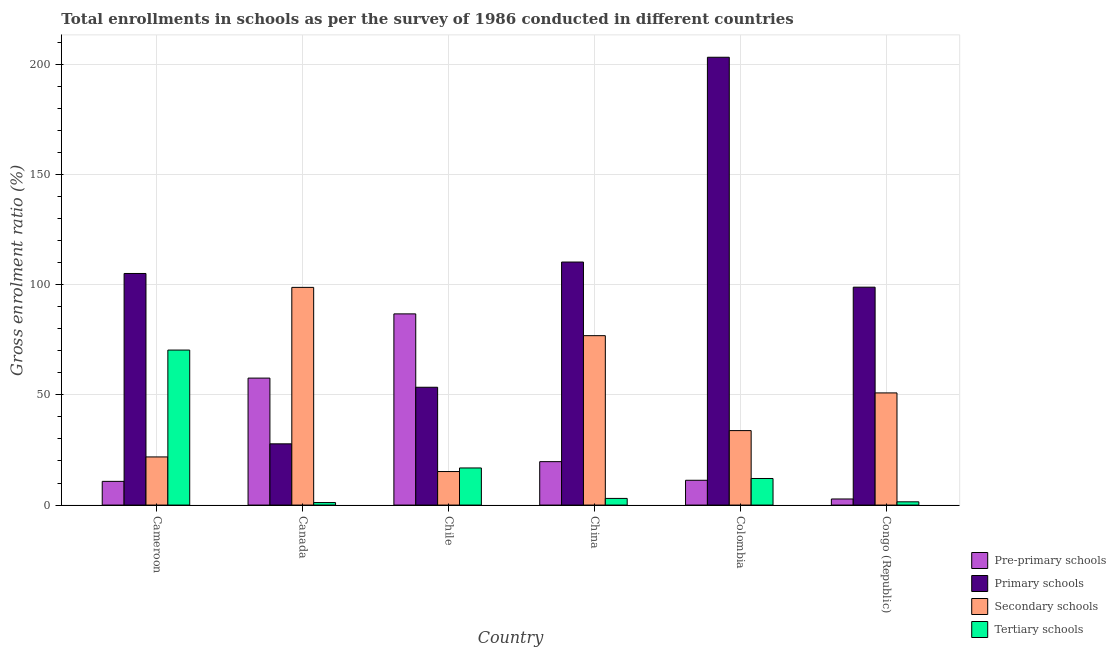How many different coloured bars are there?
Your answer should be compact. 4. How many groups of bars are there?
Make the answer very short. 6. How many bars are there on the 6th tick from the left?
Provide a short and direct response. 4. How many bars are there on the 2nd tick from the right?
Offer a very short reply. 4. What is the gross enrolment ratio in pre-primary schools in Cameroon?
Provide a succinct answer. 10.75. Across all countries, what is the maximum gross enrolment ratio in pre-primary schools?
Provide a succinct answer. 86.73. Across all countries, what is the minimum gross enrolment ratio in primary schools?
Your answer should be compact. 27.78. In which country was the gross enrolment ratio in primary schools maximum?
Ensure brevity in your answer.  Colombia. What is the total gross enrolment ratio in secondary schools in the graph?
Keep it short and to the point. 297.31. What is the difference between the gross enrolment ratio in pre-primary schools in Cameroon and that in Colombia?
Your answer should be very brief. -0.5. What is the difference between the gross enrolment ratio in secondary schools in Canada and the gross enrolment ratio in primary schools in Cameroon?
Your response must be concise. -6.31. What is the average gross enrolment ratio in primary schools per country?
Ensure brevity in your answer.  99.75. What is the difference between the gross enrolment ratio in tertiary schools and gross enrolment ratio in pre-primary schools in Chile?
Your answer should be compact. -69.9. What is the ratio of the gross enrolment ratio in tertiary schools in Cameroon to that in Chile?
Give a very brief answer. 4.18. Is the gross enrolment ratio in primary schools in Canada less than that in China?
Give a very brief answer. Yes. Is the difference between the gross enrolment ratio in secondary schools in Cameroon and Colombia greater than the difference between the gross enrolment ratio in pre-primary schools in Cameroon and Colombia?
Keep it short and to the point. No. What is the difference between the highest and the second highest gross enrolment ratio in pre-primary schools?
Keep it short and to the point. 29.14. What is the difference between the highest and the lowest gross enrolment ratio in pre-primary schools?
Offer a very short reply. 83.97. Is it the case that in every country, the sum of the gross enrolment ratio in tertiary schools and gross enrolment ratio in pre-primary schools is greater than the sum of gross enrolment ratio in secondary schools and gross enrolment ratio in primary schools?
Give a very brief answer. No. What does the 3rd bar from the left in Chile represents?
Provide a short and direct response. Secondary schools. What does the 3rd bar from the right in Chile represents?
Your response must be concise. Primary schools. How many bars are there?
Ensure brevity in your answer.  24. Are all the bars in the graph horizontal?
Your response must be concise. No. Where does the legend appear in the graph?
Ensure brevity in your answer.  Bottom right. How are the legend labels stacked?
Your answer should be very brief. Vertical. What is the title of the graph?
Keep it short and to the point. Total enrollments in schools as per the survey of 1986 conducted in different countries. Does "Social Protection" appear as one of the legend labels in the graph?
Give a very brief answer. No. What is the label or title of the X-axis?
Offer a very short reply. Country. What is the label or title of the Y-axis?
Make the answer very short. Gross enrolment ratio (%). What is the Gross enrolment ratio (%) in Pre-primary schools in Cameroon?
Your answer should be very brief. 10.75. What is the Gross enrolment ratio (%) of Primary schools in Cameroon?
Provide a short and direct response. 105.06. What is the Gross enrolment ratio (%) of Secondary schools in Cameroon?
Offer a terse response. 21.84. What is the Gross enrolment ratio (%) of Tertiary schools in Cameroon?
Make the answer very short. 70.31. What is the Gross enrolment ratio (%) in Pre-primary schools in Canada?
Ensure brevity in your answer.  57.6. What is the Gross enrolment ratio (%) in Primary schools in Canada?
Your answer should be compact. 27.78. What is the Gross enrolment ratio (%) in Secondary schools in Canada?
Ensure brevity in your answer.  98.75. What is the Gross enrolment ratio (%) of Tertiary schools in Canada?
Provide a short and direct response. 1.14. What is the Gross enrolment ratio (%) in Pre-primary schools in Chile?
Provide a short and direct response. 86.73. What is the Gross enrolment ratio (%) of Primary schools in Chile?
Ensure brevity in your answer.  53.45. What is the Gross enrolment ratio (%) in Secondary schools in Chile?
Give a very brief answer. 15.21. What is the Gross enrolment ratio (%) of Tertiary schools in Chile?
Offer a terse response. 16.84. What is the Gross enrolment ratio (%) in Pre-primary schools in China?
Give a very brief answer. 19.7. What is the Gross enrolment ratio (%) in Primary schools in China?
Keep it short and to the point. 110.25. What is the Gross enrolment ratio (%) in Secondary schools in China?
Your answer should be very brief. 76.85. What is the Gross enrolment ratio (%) in Tertiary schools in China?
Your response must be concise. 3.02. What is the Gross enrolment ratio (%) of Pre-primary schools in Colombia?
Provide a succinct answer. 11.25. What is the Gross enrolment ratio (%) in Primary schools in Colombia?
Give a very brief answer. 203.14. What is the Gross enrolment ratio (%) of Secondary schools in Colombia?
Offer a very short reply. 33.78. What is the Gross enrolment ratio (%) in Tertiary schools in Colombia?
Give a very brief answer. 12.06. What is the Gross enrolment ratio (%) in Pre-primary schools in Congo (Republic)?
Offer a terse response. 2.76. What is the Gross enrolment ratio (%) in Primary schools in Congo (Republic)?
Provide a short and direct response. 98.85. What is the Gross enrolment ratio (%) in Secondary schools in Congo (Republic)?
Provide a succinct answer. 50.88. What is the Gross enrolment ratio (%) in Tertiary schools in Congo (Republic)?
Offer a terse response. 1.48. Across all countries, what is the maximum Gross enrolment ratio (%) of Pre-primary schools?
Keep it short and to the point. 86.73. Across all countries, what is the maximum Gross enrolment ratio (%) in Primary schools?
Offer a very short reply. 203.14. Across all countries, what is the maximum Gross enrolment ratio (%) in Secondary schools?
Make the answer very short. 98.75. Across all countries, what is the maximum Gross enrolment ratio (%) of Tertiary schools?
Your answer should be compact. 70.31. Across all countries, what is the minimum Gross enrolment ratio (%) of Pre-primary schools?
Provide a succinct answer. 2.76. Across all countries, what is the minimum Gross enrolment ratio (%) of Primary schools?
Make the answer very short. 27.78. Across all countries, what is the minimum Gross enrolment ratio (%) of Secondary schools?
Your answer should be very brief. 15.21. Across all countries, what is the minimum Gross enrolment ratio (%) of Tertiary schools?
Your answer should be very brief. 1.14. What is the total Gross enrolment ratio (%) of Pre-primary schools in the graph?
Your answer should be very brief. 188.79. What is the total Gross enrolment ratio (%) in Primary schools in the graph?
Give a very brief answer. 598.52. What is the total Gross enrolment ratio (%) in Secondary schools in the graph?
Provide a short and direct response. 297.31. What is the total Gross enrolment ratio (%) in Tertiary schools in the graph?
Ensure brevity in your answer.  104.84. What is the difference between the Gross enrolment ratio (%) of Pre-primary schools in Cameroon and that in Canada?
Keep it short and to the point. -46.84. What is the difference between the Gross enrolment ratio (%) of Primary schools in Cameroon and that in Canada?
Make the answer very short. 77.28. What is the difference between the Gross enrolment ratio (%) of Secondary schools in Cameroon and that in Canada?
Ensure brevity in your answer.  -76.91. What is the difference between the Gross enrolment ratio (%) in Tertiary schools in Cameroon and that in Canada?
Your answer should be very brief. 69.17. What is the difference between the Gross enrolment ratio (%) of Pre-primary schools in Cameroon and that in Chile?
Give a very brief answer. -75.98. What is the difference between the Gross enrolment ratio (%) in Primary schools in Cameroon and that in Chile?
Your answer should be very brief. 51.61. What is the difference between the Gross enrolment ratio (%) in Secondary schools in Cameroon and that in Chile?
Make the answer very short. 6.63. What is the difference between the Gross enrolment ratio (%) in Tertiary schools in Cameroon and that in Chile?
Provide a short and direct response. 53.48. What is the difference between the Gross enrolment ratio (%) of Pre-primary schools in Cameroon and that in China?
Give a very brief answer. -8.95. What is the difference between the Gross enrolment ratio (%) in Primary schools in Cameroon and that in China?
Your answer should be compact. -5.19. What is the difference between the Gross enrolment ratio (%) in Secondary schools in Cameroon and that in China?
Keep it short and to the point. -55.01. What is the difference between the Gross enrolment ratio (%) of Tertiary schools in Cameroon and that in China?
Make the answer very short. 67.29. What is the difference between the Gross enrolment ratio (%) in Pre-primary schools in Cameroon and that in Colombia?
Your response must be concise. -0.5. What is the difference between the Gross enrolment ratio (%) in Primary schools in Cameroon and that in Colombia?
Give a very brief answer. -98.08. What is the difference between the Gross enrolment ratio (%) in Secondary schools in Cameroon and that in Colombia?
Your answer should be very brief. -11.95. What is the difference between the Gross enrolment ratio (%) in Tertiary schools in Cameroon and that in Colombia?
Provide a short and direct response. 58.25. What is the difference between the Gross enrolment ratio (%) in Pre-primary schools in Cameroon and that in Congo (Republic)?
Ensure brevity in your answer.  7.99. What is the difference between the Gross enrolment ratio (%) of Primary schools in Cameroon and that in Congo (Republic)?
Keep it short and to the point. 6.21. What is the difference between the Gross enrolment ratio (%) of Secondary schools in Cameroon and that in Congo (Republic)?
Give a very brief answer. -29.04. What is the difference between the Gross enrolment ratio (%) in Tertiary schools in Cameroon and that in Congo (Republic)?
Provide a succinct answer. 68.83. What is the difference between the Gross enrolment ratio (%) in Pre-primary schools in Canada and that in Chile?
Make the answer very short. -29.14. What is the difference between the Gross enrolment ratio (%) in Primary schools in Canada and that in Chile?
Offer a terse response. -25.67. What is the difference between the Gross enrolment ratio (%) of Secondary schools in Canada and that in Chile?
Offer a very short reply. 83.54. What is the difference between the Gross enrolment ratio (%) in Tertiary schools in Canada and that in Chile?
Offer a very short reply. -15.69. What is the difference between the Gross enrolment ratio (%) in Pre-primary schools in Canada and that in China?
Your answer should be compact. 37.9. What is the difference between the Gross enrolment ratio (%) in Primary schools in Canada and that in China?
Offer a terse response. -82.47. What is the difference between the Gross enrolment ratio (%) of Secondary schools in Canada and that in China?
Provide a short and direct response. 21.9. What is the difference between the Gross enrolment ratio (%) of Tertiary schools in Canada and that in China?
Keep it short and to the point. -1.88. What is the difference between the Gross enrolment ratio (%) of Pre-primary schools in Canada and that in Colombia?
Your answer should be compact. 46.34. What is the difference between the Gross enrolment ratio (%) of Primary schools in Canada and that in Colombia?
Make the answer very short. -175.36. What is the difference between the Gross enrolment ratio (%) of Secondary schools in Canada and that in Colombia?
Give a very brief answer. 64.96. What is the difference between the Gross enrolment ratio (%) in Tertiary schools in Canada and that in Colombia?
Offer a very short reply. -10.92. What is the difference between the Gross enrolment ratio (%) in Pre-primary schools in Canada and that in Congo (Republic)?
Provide a succinct answer. 54.83. What is the difference between the Gross enrolment ratio (%) in Primary schools in Canada and that in Congo (Republic)?
Give a very brief answer. -71.07. What is the difference between the Gross enrolment ratio (%) of Secondary schools in Canada and that in Congo (Republic)?
Offer a very short reply. 47.87. What is the difference between the Gross enrolment ratio (%) in Tertiary schools in Canada and that in Congo (Republic)?
Your response must be concise. -0.34. What is the difference between the Gross enrolment ratio (%) of Pre-primary schools in Chile and that in China?
Ensure brevity in your answer.  67.03. What is the difference between the Gross enrolment ratio (%) in Primary schools in Chile and that in China?
Offer a terse response. -56.8. What is the difference between the Gross enrolment ratio (%) of Secondary schools in Chile and that in China?
Offer a terse response. -61.64. What is the difference between the Gross enrolment ratio (%) of Tertiary schools in Chile and that in China?
Your answer should be very brief. 13.81. What is the difference between the Gross enrolment ratio (%) of Pre-primary schools in Chile and that in Colombia?
Provide a short and direct response. 75.48. What is the difference between the Gross enrolment ratio (%) of Primary schools in Chile and that in Colombia?
Provide a short and direct response. -149.69. What is the difference between the Gross enrolment ratio (%) of Secondary schools in Chile and that in Colombia?
Keep it short and to the point. -18.58. What is the difference between the Gross enrolment ratio (%) of Tertiary schools in Chile and that in Colombia?
Provide a succinct answer. 4.78. What is the difference between the Gross enrolment ratio (%) of Pre-primary schools in Chile and that in Congo (Republic)?
Your answer should be compact. 83.97. What is the difference between the Gross enrolment ratio (%) in Primary schools in Chile and that in Congo (Republic)?
Your answer should be very brief. -45.4. What is the difference between the Gross enrolment ratio (%) of Secondary schools in Chile and that in Congo (Republic)?
Your answer should be very brief. -35.67. What is the difference between the Gross enrolment ratio (%) of Tertiary schools in Chile and that in Congo (Republic)?
Your answer should be very brief. 15.36. What is the difference between the Gross enrolment ratio (%) of Pre-primary schools in China and that in Colombia?
Make the answer very short. 8.45. What is the difference between the Gross enrolment ratio (%) of Primary schools in China and that in Colombia?
Make the answer very short. -92.89. What is the difference between the Gross enrolment ratio (%) in Secondary schools in China and that in Colombia?
Offer a terse response. 43.06. What is the difference between the Gross enrolment ratio (%) of Tertiary schools in China and that in Colombia?
Ensure brevity in your answer.  -9.04. What is the difference between the Gross enrolment ratio (%) in Pre-primary schools in China and that in Congo (Republic)?
Your answer should be compact. 16.94. What is the difference between the Gross enrolment ratio (%) in Primary schools in China and that in Congo (Republic)?
Provide a short and direct response. 11.4. What is the difference between the Gross enrolment ratio (%) of Secondary schools in China and that in Congo (Republic)?
Your response must be concise. 25.97. What is the difference between the Gross enrolment ratio (%) in Tertiary schools in China and that in Congo (Republic)?
Offer a very short reply. 1.54. What is the difference between the Gross enrolment ratio (%) in Pre-primary schools in Colombia and that in Congo (Republic)?
Offer a terse response. 8.49. What is the difference between the Gross enrolment ratio (%) in Primary schools in Colombia and that in Congo (Republic)?
Your answer should be compact. 104.3. What is the difference between the Gross enrolment ratio (%) of Secondary schools in Colombia and that in Congo (Republic)?
Make the answer very short. -17.1. What is the difference between the Gross enrolment ratio (%) in Tertiary schools in Colombia and that in Congo (Republic)?
Provide a short and direct response. 10.58. What is the difference between the Gross enrolment ratio (%) in Pre-primary schools in Cameroon and the Gross enrolment ratio (%) in Primary schools in Canada?
Provide a succinct answer. -17.02. What is the difference between the Gross enrolment ratio (%) of Pre-primary schools in Cameroon and the Gross enrolment ratio (%) of Secondary schools in Canada?
Offer a terse response. -88. What is the difference between the Gross enrolment ratio (%) in Pre-primary schools in Cameroon and the Gross enrolment ratio (%) in Tertiary schools in Canada?
Offer a very short reply. 9.61. What is the difference between the Gross enrolment ratio (%) of Primary schools in Cameroon and the Gross enrolment ratio (%) of Secondary schools in Canada?
Make the answer very short. 6.31. What is the difference between the Gross enrolment ratio (%) in Primary schools in Cameroon and the Gross enrolment ratio (%) in Tertiary schools in Canada?
Offer a very short reply. 103.92. What is the difference between the Gross enrolment ratio (%) in Secondary schools in Cameroon and the Gross enrolment ratio (%) in Tertiary schools in Canada?
Offer a terse response. 20.7. What is the difference between the Gross enrolment ratio (%) of Pre-primary schools in Cameroon and the Gross enrolment ratio (%) of Primary schools in Chile?
Your answer should be compact. -42.69. What is the difference between the Gross enrolment ratio (%) of Pre-primary schools in Cameroon and the Gross enrolment ratio (%) of Secondary schools in Chile?
Make the answer very short. -4.46. What is the difference between the Gross enrolment ratio (%) of Pre-primary schools in Cameroon and the Gross enrolment ratio (%) of Tertiary schools in Chile?
Provide a short and direct response. -6.08. What is the difference between the Gross enrolment ratio (%) in Primary schools in Cameroon and the Gross enrolment ratio (%) in Secondary schools in Chile?
Make the answer very short. 89.85. What is the difference between the Gross enrolment ratio (%) in Primary schools in Cameroon and the Gross enrolment ratio (%) in Tertiary schools in Chile?
Offer a very short reply. 88.22. What is the difference between the Gross enrolment ratio (%) of Secondary schools in Cameroon and the Gross enrolment ratio (%) of Tertiary schools in Chile?
Provide a short and direct response. 5. What is the difference between the Gross enrolment ratio (%) in Pre-primary schools in Cameroon and the Gross enrolment ratio (%) in Primary schools in China?
Provide a short and direct response. -99.5. What is the difference between the Gross enrolment ratio (%) in Pre-primary schools in Cameroon and the Gross enrolment ratio (%) in Secondary schools in China?
Ensure brevity in your answer.  -66.1. What is the difference between the Gross enrolment ratio (%) of Pre-primary schools in Cameroon and the Gross enrolment ratio (%) of Tertiary schools in China?
Your answer should be compact. 7.73. What is the difference between the Gross enrolment ratio (%) in Primary schools in Cameroon and the Gross enrolment ratio (%) in Secondary schools in China?
Your answer should be very brief. 28.21. What is the difference between the Gross enrolment ratio (%) of Primary schools in Cameroon and the Gross enrolment ratio (%) of Tertiary schools in China?
Make the answer very short. 102.04. What is the difference between the Gross enrolment ratio (%) in Secondary schools in Cameroon and the Gross enrolment ratio (%) in Tertiary schools in China?
Ensure brevity in your answer.  18.82. What is the difference between the Gross enrolment ratio (%) in Pre-primary schools in Cameroon and the Gross enrolment ratio (%) in Primary schools in Colombia?
Offer a terse response. -192.39. What is the difference between the Gross enrolment ratio (%) of Pre-primary schools in Cameroon and the Gross enrolment ratio (%) of Secondary schools in Colombia?
Offer a very short reply. -23.03. What is the difference between the Gross enrolment ratio (%) in Pre-primary schools in Cameroon and the Gross enrolment ratio (%) in Tertiary schools in Colombia?
Your response must be concise. -1.3. What is the difference between the Gross enrolment ratio (%) of Primary schools in Cameroon and the Gross enrolment ratio (%) of Secondary schools in Colombia?
Your answer should be compact. 71.27. What is the difference between the Gross enrolment ratio (%) of Primary schools in Cameroon and the Gross enrolment ratio (%) of Tertiary schools in Colombia?
Provide a short and direct response. 93. What is the difference between the Gross enrolment ratio (%) of Secondary schools in Cameroon and the Gross enrolment ratio (%) of Tertiary schools in Colombia?
Make the answer very short. 9.78. What is the difference between the Gross enrolment ratio (%) in Pre-primary schools in Cameroon and the Gross enrolment ratio (%) in Primary schools in Congo (Republic)?
Your answer should be very brief. -88.09. What is the difference between the Gross enrolment ratio (%) in Pre-primary schools in Cameroon and the Gross enrolment ratio (%) in Secondary schools in Congo (Republic)?
Your answer should be compact. -40.13. What is the difference between the Gross enrolment ratio (%) in Pre-primary schools in Cameroon and the Gross enrolment ratio (%) in Tertiary schools in Congo (Republic)?
Provide a succinct answer. 9.28. What is the difference between the Gross enrolment ratio (%) in Primary schools in Cameroon and the Gross enrolment ratio (%) in Secondary schools in Congo (Republic)?
Provide a short and direct response. 54.18. What is the difference between the Gross enrolment ratio (%) in Primary schools in Cameroon and the Gross enrolment ratio (%) in Tertiary schools in Congo (Republic)?
Offer a very short reply. 103.58. What is the difference between the Gross enrolment ratio (%) of Secondary schools in Cameroon and the Gross enrolment ratio (%) of Tertiary schools in Congo (Republic)?
Your answer should be compact. 20.36. What is the difference between the Gross enrolment ratio (%) in Pre-primary schools in Canada and the Gross enrolment ratio (%) in Primary schools in Chile?
Keep it short and to the point. 4.15. What is the difference between the Gross enrolment ratio (%) of Pre-primary schools in Canada and the Gross enrolment ratio (%) of Secondary schools in Chile?
Provide a succinct answer. 42.39. What is the difference between the Gross enrolment ratio (%) of Pre-primary schools in Canada and the Gross enrolment ratio (%) of Tertiary schools in Chile?
Offer a terse response. 40.76. What is the difference between the Gross enrolment ratio (%) in Primary schools in Canada and the Gross enrolment ratio (%) in Secondary schools in Chile?
Provide a short and direct response. 12.57. What is the difference between the Gross enrolment ratio (%) of Primary schools in Canada and the Gross enrolment ratio (%) of Tertiary schools in Chile?
Give a very brief answer. 10.94. What is the difference between the Gross enrolment ratio (%) of Secondary schools in Canada and the Gross enrolment ratio (%) of Tertiary schools in Chile?
Your response must be concise. 81.91. What is the difference between the Gross enrolment ratio (%) in Pre-primary schools in Canada and the Gross enrolment ratio (%) in Primary schools in China?
Provide a succinct answer. -52.65. What is the difference between the Gross enrolment ratio (%) of Pre-primary schools in Canada and the Gross enrolment ratio (%) of Secondary schools in China?
Keep it short and to the point. -19.25. What is the difference between the Gross enrolment ratio (%) in Pre-primary schools in Canada and the Gross enrolment ratio (%) in Tertiary schools in China?
Offer a very short reply. 54.58. What is the difference between the Gross enrolment ratio (%) in Primary schools in Canada and the Gross enrolment ratio (%) in Secondary schools in China?
Your answer should be compact. -49.07. What is the difference between the Gross enrolment ratio (%) of Primary schools in Canada and the Gross enrolment ratio (%) of Tertiary schools in China?
Provide a succinct answer. 24.76. What is the difference between the Gross enrolment ratio (%) in Secondary schools in Canada and the Gross enrolment ratio (%) in Tertiary schools in China?
Keep it short and to the point. 95.73. What is the difference between the Gross enrolment ratio (%) in Pre-primary schools in Canada and the Gross enrolment ratio (%) in Primary schools in Colombia?
Make the answer very short. -145.55. What is the difference between the Gross enrolment ratio (%) in Pre-primary schools in Canada and the Gross enrolment ratio (%) in Secondary schools in Colombia?
Give a very brief answer. 23.81. What is the difference between the Gross enrolment ratio (%) of Pre-primary schools in Canada and the Gross enrolment ratio (%) of Tertiary schools in Colombia?
Offer a terse response. 45.54. What is the difference between the Gross enrolment ratio (%) in Primary schools in Canada and the Gross enrolment ratio (%) in Secondary schools in Colombia?
Your response must be concise. -6.01. What is the difference between the Gross enrolment ratio (%) of Primary schools in Canada and the Gross enrolment ratio (%) of Tertiary schools in Colombia?
Offer a terse response. 15.72. What is the difference between the Gross enrolment ratio (%) in Secondary schools in Canada and the Gross enrolment ratio (%) in Tertiary schools in Colombia?
Your answer should be compact. 86.69. What is the difference between the Gross enrolment ratio (%) in Pre-primary schools in Canada and the Gross enrolment ratio (%) in Primary schools in Congo (Republic)?
Provide a short and direct response. -41.25. What is the difference between the Gross enrolment ratio (%) in Pre-primary schools in Canada and the Gross enrolment ratio (%) in Secondary schools in Congo (Republic)?
Provide a succinct answer. 6.71. What is the difference between the Gross enrolment ratio (%) of Pre-primary schools in Canada and the Gross enrolment ratio (%) of Tertiary schools in Congo (Republic)?
Provide a short and direct response. 56.12. What is the difference between the Gross enrolment ratio (%) in Primary schools in Canada and the Gross enrolment ratio (%) in Secondary schools in Congo (Republic)?
Your answer should be compact. -23.11. What is the difference between the Gross enrolment ratio (%) in Primary schools in Canada and the Gross enrolment ratio (%) in Tertiary schools in Congo (Republic)?
Your response must be concise. 26.3. What is the difference between the Gross enrolment ratio (%) in Secondary schools in Canada and the Gross enrolment ratio (%) in Tertiary schools in Congo (Republic)?
Ensure brevity in your answer.  97.27. What is the difference between the Gross enrolment ratio (%) in Pre-primary schools in Chile and the Gross enrolment ratio (%) in Primary schools in China?
Keep it short and to the point. -23.52. What is the difference between the Gross enrolment ratio (%) in Pre-primary schools in Chile and the Gross enrolment ratio (%) in Secondary schools in China?
Offer a terse response. 9.88. What is the difference between the Gross enrolment ratio (%) in Pre-primary schools in Chile and the Gross enrolment ratio (%) in Tertiary schools in China?
Your answer should be compact. 83.71. What is the difference between the Gross enrolment ratio (%) of Primary schools in Chile and the Gross enrolment ratio (%) of Secondary schools in China?
Ensure brevity in your answer.  -23.4. What is the difference between the Gross enrolment ratio (%) in Primary schools in Chile and the Gross enrolment ratio (%) in Tertiary schools in China?
Offer a terse response. 50.43. What is the difference between the Gross enrolment ratio (%) of Secondary schools in Chile and the Gross enrolment ratio (%) of Tertiary schools in China?
Ensure brevity in your answer.  12.19. What is the difference between the Gross enrolment ratio (%) of Pre-primary schools in Chile and the Gross enrolment ratio (%) of Primary schools in Colombia?
Provide a succinct answer. -116.41. What is the difference between the Gross enrolment ratio (%) in Pre-primary schools in Chile and the Gross enrolment ratio (%) in Secondary schools in Colombia?
Your response must be concise. 52.95. What is the difference between the Gross enrolment ratio (%) in Pre-primary schools in Chile and the Gross enrolment ratio (%) in Tertiary schools in Colombia?
Keep it short and to the point. 74.67. What is the difference between the Gross enrolment ratio (%) of Primary schools in Chile and the Gross enrolment ratio (%) of Secondary schools in Colombia?
Your answer should be very brief. 19.66. What is the difference between the Gross enrolment ratio (%) in Primary schools in Chile and the Gross enrolment ratio (%) in Tertiary schools in Colombia?
Make the answer very short. 41.39. What is the difference between the Gross enrolment ratio (%) of Secondary schools in Chile and the Gross enrolment ratio (%) of Tertiary schools in Colombia?
Provide a short and direct response. 3.15. What is the difference between the Gross enrolment ratio (%) of Pre-primary schools in Chile and the Gross enrolment ratio (%) of Primary schools in Congo (Republic)?
Ensure brevity in your answer.  -12.11. What is the difference between the Gross enrolment ratio (%) of Pre-primary schools in Chile and the Gross enrolment ratio (%) of Secondary schools in Congo (Republic)?
Offer a terse response. 35.85. What is the difference between the Gross enrolment ratio (%) of Pre-primary schools in Chile and the Gross enrolment ratio (%) of Tertiary schools in Congo (Republic)?
Ensure brevity in your answer.  85.25. What is the difference between the Gross enrolment ratio (%) in Primary schools in Chile and the Gross enrolment ratio (%) in Secondary schools in Congo (Republic)?
Provide a succinct answer. 2.56. What is the difference between the Gross enrolment ratio (%) in Primary schools in Chile and the Gross enrolment ratio (%) in Tertiary schools in Congo (Republic)?
Your response must be concise. 51.97. What is the difference between the Gross enrolment ratio (%) in Secondary schools in Chile and the Gross enrolment ratio (%) in Tertiary schools in Congo (Republic)?
Give a very brief answer. 13.73. What is the difference between the Gross enrolment ratio (%) in Pre-primary schools in China and the Gross enrolment ratio (%) in Primary schools in Colombia?
Your answer should be compact. -183.44. What is the difference between the Gross enrolment ratio (%) of Pre-primary schools in China and the Gross enrolment ratio (%) of Secondary schools in Colombia?
Your answer should be compact. -14.09. What is the difference between the Gross enrolment ratio (%) in Pre-primary schools in China and the Gross enrolment ratio (%) in Tertiary schools in Colombia?
Your answer should be very brief. 7.64. What is the difference between the Gross enrolment ratio (%) of Primary schools in China and the Gross enrolment ratio (%) of Secondary schools in Colombia?
Provide a succinct answer. 76.46. What is the difference between the Gross enrolment ratio (%) of Primary schools in China and the Gross enrolment ratio (%) of Tertiary schools in Colombia?
Ensure brevity in your answer.  98.19. What is the difference between the Gross enrolment ratio (%) in Secondary schools in China and the Gross enrolment ratio (%) in Tertiary schools in Colombia?
Ensure brevity in your answer.  64.79. What is the difference between the Gross enrolment ratio (%) of Pre-primary schools in China and the Gross enrolment ratio (%) of Primary schools in Congo (Republic)?
Offer a very short reply. -79.15. What is the difference between the Gross enrolment ratio (%) of Pre-primary schools in China and the Gross enrolment ratio (%) of Secondary schools in Congo (Republic)?
Offer a very short reply. -31.18. What is the difference between the Gross enrolment ratio (%) in Pre-primary schools in China and the Gross enrolment ratio (%) in Tertiary schools in Congo (Republic)?
Offer a very short reply. 18.22. What is the difference between the Gross enrolment ratio (%) of Primary schools in China and the Gross enrolment ratio (%) of Secondary schools in Congo (Republic)?
Your answer should be compact. 59.37. What is the difference between the Gross enrolment ratio (%) in Primary schools in China and the Gross enrolment ratio (%) in Tertiary schools in Congo (Republic)?
Your answer should be compact. 108.77. What is the difference between the Gross enrolment ratio (%) in Secondary schools in China and the Gross enrolment ratio (%) in Tertiary schools in Congo (Republic)?
Offer a very short reply. 75.37. What is the difference between the Gross enrolment ratio (%) of Pre-primary schools in Colombia and the Gross enrolment ratio (%) of Primary schools in Congo (Republic)?
Offer a terse response. -87.59. What is the difference between the Gross enrolment ratio (%) of Pre-primary schools in Colombia and the Gross enrolment ratio (%) of Secondary schools in Congo (Republic)?
Offer a very short reply. -39.63. What is the difference between the Gross enrolment ratio (%) in Pre-primary schools in Colombia and the Gross enrolment ratio (%) in Tertiary schools in Congo (Republic)?
Make the answer very short. 9.78. What is the difference between the Gross enrolment ratio (%) of Primary schools in Colombia and the Gross enrolment ratio (%) of Secondary schools in Congo (Republic)?
Your response must be concise. 152.26. What is the difference between the Gross enrolment ratio (%) of Primary schools in Colombia and the Gross enrolment ratio (%) of Tertiary schools in Congo (Republic)?
Offer a very short reply. 201.66. What is the difference between the Gross enrolment ratio (%) of Secondary schools in Colombia and the Gross enrolment ratio (%) of Tertiary schools in Congo (Republic)?
Offer a terse response. 32.31. What is the average Gross enrolment ratio (%) of Pre-primary schools per country?
Your answer should be compact. 31.47. What is the average Gross enrolment ratio (%) in Primary schools per country?
Provide a succinct answer. 99.75. What is the average Gross enrolment ratio (%) of Secondary schools per country?
Offer a very short reply. 49.55. What is the average Gross enrolment ratio (%) in Tertiary schools per country?
Your response must be concise. 17.47. What is the difference between the Gross enrolment ratio (%) in Pre-primary schools and Gross enrolment ratio (%) in Primary schools in Cameroon?
Give a very brief answer. -94.31. What is the difference between the Gross enrolment ratio (%) of Pre-primary schools and Gross enrolment ratio (%) of Secondary schools in Cameroon?
Provide a short and direct response. -11.09. What is the difference between the Gross enrolment ratio (%) of Pre-primary schools and Gross enrolment ratio (%) of Tertiary schools in Cameroon?
Keep it short and to the point. -59.56. What is the difference between the Gross enrolment ratio (%) in Primary schools and Gross enrolment ratio (%) in Secondary schools in Cameroon?
Provide a succinct answer. 83.22. What is the difference between the Gross enrolment ratio (%) of Primary schools and Gross enrolment ratio (%) of Tertiary schools in Cameroon?
Ensure brevity in your answer.  34.75. What is the difference between the Gross enrolment ratio (%) of Secondary schools and Gross enrolment ratio (%) of Tertiary schools in Cameroon?
Provide a short and direct response. -48.47. What is the difference between the Gross enrolment ratio (%) of Pre-primary schools and Gross enrolment ratio (%) of Primary schools in Canada?
Keep it short and to the point. 29.82. What is the difference between the Gross enrolment ratio (%) in Pre-primary schools and Gross enrolment ratio (%) in Secondary schools in Canada?
Your response must be concise. -41.15. What is the difference between the Gross enrolment ratio (%) of Pre-primary schools and Gross enrolment ratio (%) of Tertiary schools in Canada?
Give a very brief answer. 56.46. What is the difference between the Gross enrolment ratio (%) of Primary schools and Gross enrolment ratio (%) of Secondary schools in Canada?
Your response must be concise. -70.97. What is the difference between the Gross enrolment ratio (%) in Primary schools and Gross enrolment ratio (%) in Tertiary schools in Canada?
Keep it short and to the point. 26.64. What is the difference between the Gross enrolment ratio (%) of Secondary schools and Gross enrolment ratio (%) of Tertiary schools in Canada?
Make the answer very short. 97.61. What is the difference between the Gross enrolment ratio (%) of Pre-primary schools and Gross enrolment ratio (%) of Primary schools in Chile?
Your response must be concise. 33.28. What is the difference between the Gross enrolment ratio (%) in Pre-primary schools and Gross enrolment ratio (%) in Secondary schools in Chile?
Your response must be concise. 71.52. What is the difference between the Gross enrolment ratio (%) of Pre-primary schools and Gross enrolment ratio (%) of Tertiary schools in Chile?
Your response must be concise. 69.9. What is the difference between the Gross enrolment ratio (%) in Primary schools and Gross enrolment ratio (%) in Secondary schools in Chile?
Give a very brief answer. 38.24. What is the difference between the Gross enrolment ratio (%) in Primary schools and Gross enrolment ratio (%) in Tertiary schools in Chile?
Give a very brief answer. 36.61. What is the difference between the Gross enrolment ratio (%) of Secondary schools and Gross enrolment ratio (%) of Tertiary schools in Chile?
Provide a succinct answer. -1.63. What is the difference between the Gross enrolment ratio (%) of Pre-primary schools and Gross enrolment ratio (%) of Primary schools in China?
Your answer should be compact. -90.55. What is the difference between the Gross enrolment ratio (%) in Pre-primary schools and Gross enrolment ratio (%) in Secondary schools in China?
Ensure brevity in your answer.  -57.15. What is the difference between the Gross enrolment ratio (%) in Pre-primary schools and Gross enrolment ratio (%) in Tertiary schools in China?
Ensure brevity in your answer.  16.68. What is the difference between the Gross enrolment ratio (%) of Primary schools and Gross enrolment ratio (%) of Secondary schools in China?
Provide a succinct answer. 33.4. What is the difference between the Gross enrolment ratio (%) of Primary schools and Gross enrolment ratio (%) of Tertiary schools in China?
Your answer should be very brief. 107.23. What is the difference between the Gross enrolment ratio (%) of Secondary schools and Gross enrolment ratio (%) of Tertiary schools in China?
Provide a short and direct response. 73.83. What is the difference between the Gross enrolment ratio (%) of Pre-primary schools and Gross enrolment ratio (%) of Primary schools in Colombia?
Your answer should be very brief. -191.89. What is the difference between the Gross enrolment ratio (%) in Pre-primary schools and Gross enrolment ratio (%) in Secondary schools in Colombia?
Make the answer very short. -22.53. What is the difference between the Gross enrolment ratio (%) of Pre-primary schools and Gross enrolment ratio (%) of Tertiary schools in Colombia?
Provide a succinct answer. -0.8. What is the difference between the Gross enrolment ratio (%) in Primary schools and Gross enrolment ratio (%) in Secondary schools in Colombia?
Give a very brief answer. 169.36. What is the difference between the Gross enrolment ratio (%) in Primary schools and Gross enrolment ratio (%) in Tertiary schools in Colombia?
Offer a very short reply. 191.08. What is the difference between the Gross enrolment ratio (%) in Secondary schools and Gross enrolment ratio (%) in Tertiary schools in Colombia?
Keep it short and to the point. 21.73. What is the difference between the Gross enrolment ratio (%) of Pre-primary schools and Gross enrolment ratio (%) of Primary schools in Congo (Republic)?
Your response must be concise. -96.08. What is the difference between the Gross enrolment ratio (%) in Pre-primary schools and Gross enrolment ratio (%) in Secondary schools in Congo (Republic)?
Provide a succinct answer. -48.12. What is the difference between the Gross enrolment ratio (%) in Pre-primary schools and Gross enrolment ratio (%) in Tertiary schools in Congo (Republic)?
Provide a succinct answer. 1.29. What is the difference between the Gross enrolment ratio (%) of Primary schools and Gross enrolment ratio (%) of Secondary schools in Congo (Republic)?
Provide a succinct answer. 47.96. What is the difference between the Gross enrolment ratio (%) of Primary schools and Gross enrolment ratio (%) of Tertiary schools in Congo (Republic)?
Give a very brief answer. 97.37. What is the difference between the Gross enrolment ratio (%) of Secondary schools and Gross enrolment ratio (%) of Tertiary schools in Congo (Republic)?
Keep it short and to the point. 49.41. What is the ratio of the Gross enrolment ratio (%) in Pre-primary schools in Cameroon to that in Canada?
Provide a short and direct response. 0.19. What is the ratio of the Gross enrolment ratio (%) in Primary schools in Cameroon to that in Canada?
Your response must be concise. 3.78. What is the ratio of the Gross enrolment ratio (%) of Secondary schools in Cameroon to that in Canada?
Provide a short and direct response. 0.22. What is the ratio of the Gross enrolment ratio (%) in Tertiary schools in Cameroon to that in Canada?
Provide a short and direct response. 61.63. What is the ratio of the Gross enrolment ratio (%) in Pre-primary schools in Cameroon to that in Chile?
Ensure brevity in your answer.  0.12. What is the ratio of the Gross enrolment ratio (%) in Primary schools in Cameroon to that in Chile?
Your response must be concise. 1.97. What is the ratio of the Gross enrolment ratio (%) of Secondary schools in Cameroon to that in Chile?
Offer a very short reply. 1.44. What is the ratio of the Gross enrolment ratio (%) of Tertiary schools in Cameroon to that in Chile?
Keep it short and to the point. 4.18. What is the ratio of the Gross enrolment ratio (%) of Pre-primary schools in Cameroon to that in China?
Give a very brief answer. 0.55. What is the ratio of the Gross enrolment ratio (%) of Primary schools in Cameroon to that in China?
Provide a succinct answer. 0.95. What is the ratio of the Gross enrolment ratio (%) of Secondary schools in Cameroon to that in China?
Provide a succinct answer. 0.28. What is the ratio of the Gross enrolment ratio (%) of Tertiary schools in Cameroon to that in China?
Keep it short and to the point. 23.28. What is the ratio of the Gross enrolment ratio (%) in Pre-primary schools in Cameroon to that in Colombia?
Your answer should be very brief. 0.96. What is the ratio of the Gross enrolment ratio (%) of Primary schools in Cameroon to that in Colombia?
Your answer should be very brief. 0.52. What is the ratio of the Gross enrolment ratio (%) of Secondary schools in Cameroon to that in Colombia?
Make the answer very short. 0.65. What is the ratio of the Gross enrolment ratio (%) of Tertiary schools in Cameroon to that in Colombia?
Offer a very short reply. 5.83. What is the ratio of the Gross enrolment ratio (%) in Pre-primary schools in Cameroon to that in Congo (Republic)?
Offer a very short reply. 3.89. What is the ratio of the Gross enrolment ratio (%) in Primary schools in Cameroon to that in Congo (Republic)?
Make the answer very short. 1.06. What is the ratio of the Gross enrolment ratio (%) in Secondary schools in Cameroon to that in Congo (Republic)?
Provide a short and direct response. 0.43. What is the ratio of the Gross enrolment ratio (%) in Tertiary schools in Cameroon to that in Congo (Republic)?
Ensure brevity in your answer.  47.61. What is the ratio of the Gross enrolment ratio (%) of Pre-primary schools in Canada to that in Chile?
Provide a short and direct response. 0.66. What is the ratio of the Gross enrolment ratio (%) in Primary schools in Canada to that in Chile?
Make the answer very short. 0.52. What is the ratio of the Gross enrolment ratio (%) of Secondary schools in Canada to that in Chile?
Your answer should be very brief. 6.49. What is the ratio of the Gross enrolment ratio (%) in Tertiary schools in Canada to that in Chile?
Your response must be concise. 0.07. What is the ratio of the Gross enrolment ratio (%) in Pre-primary schools in Canada to that in China?
Provide a succinct answer. 2.92. What is the ratio of the Gross enrolment ratio (%) in Primary schools in Canada to that in China?
Offer a very short reply. 0.25. What is the ratio of the Gross enrolment ratio (%) in Secondary schools in Canada to that in China?
Keep it short and to the point. 1.28. What is the ratio of the Gross enrolment ratio (%) in Tertiary schools in Canada to that in China?
Offer a very short reply. 0.38. What is the ratio of the Gross enrolment ratio (%) of Pre-primary schools in Canada to that in Colombia?
Ensure brevity in your answer.  5.12. What is the ratio of the Gross enrolment ratio (%) of Primary schools in Canada to that in Colombia?
Ensure brevity in your answer.  0.14. What is the ratio of the Gross enrolment ratio (%) in Secondary schools in Canada to that in Colombia?
Keep it short and to the point. 2.92. What is the ratio of the Gross enrolment ratio (%) in Tertiary schools in Canada to that in Colombia?
Make the answer very short. 0.09. What is the ratio of the Gross enrolment ratio (%) in Pre-primary schools in Canada to that in Congo (Republic)?
Your answer should be very brief. 20.84. What is the ratio of the Gross enrolment ratio (%) in Primary schools in Canada to that in Congo (Republic)?
Give a very brief answer. 0.28. What is the ratio of the Gross enrolment ratio (%) in Secondary schools in Canada to that in Congo (Republic)?
Make the answer very short. 1.94. What is the ratio of the Gross enrolment ratio (%) in Tertiary schools in Canada to that in Congo (Republic)?
Make the answer very short. 0.77. What is the ratio of the Gross enrolment ratio (%) of Pre-primary schools in Chile to that in China?
Make the answer very short. 4.4. What is the ratio of the Gross enrolment ratio (%) of Primary schools in Chile to that in China?
Your answer should be very brief. 0.48. What is the ratio of the Gross enrolment ratio (%) in Secondary schools in Chile to that in China?
Offer a terse response. 0.2. What is the ratio of the Gross enrolment ratio (%) in Tertiary schools in Chile to that in China?
Give a very brief answer. 5.57. What is the ratio of the Gross enrolment ratio (%) of Pre-primary schools in Chile to that in Colombia?
Ensure brevity in your answer.  7.71. What is the ratio of the Gross enrolment ratio (%) in Primary schools in Chile to that in Colombia?
Your answer should be very brief. 0.26. What is the ratio of the Gross enrolment ratio (%) of Secondary schools in Chile to that in Colombia?
Provide a succinct answer. 0.45. What is the ratio of the Gross enrolment ratio (%) of Tertiary schools in Chile to that in Colombia?
Keep it short and to the point. 1.4. What is the ratio of the Gross enrolment ratio (%) in Pre-primary schools in Chile to that in Congo (Republic)?
Your answer should be compact. 31.39. What is the ratio of the Gross enrolment ratio (%) in Primary schools in Chile to that in Congo (Republic)?
Provide a succinct answer. 0.54. What is the ratio of the Gross enrolment ratio (%) of Secondary schools in Chile to that in Congo (Republic)?
Offer a terse response. 0.3. What is the ratio of the Gross enrolment ratio (%) in Tertiary schools in Chile to that in Congo (Republic)?
Offer a terse response. 11.4. What is the ratio of the Gross enrolment ratio (%) in Pre-primary schools in China to that in Colombia?
Your response must be concise. 1.75. What is the ratio of the Gross enrolment ratio (%) in Primary schools in China to that in Colombia?
Keep it short and to the point. 0.54. What is the ratio of the Gross enrolment ratio (%) of Secondary schools in China to that in Colombia?
Your answer should be compact. 2.27. What is the ratio of the Gross enrolment ratio (%) in Tertiary schools in China to that in Colombia?
Your answer should be compact. 0.25. What is the ratio of the Gross enrolment ratio (%) in Pre-primary schools in China to that in Congo (Republic)?
Your response must be concise. 7.13. What is the ratio of the Gross enrolment ratio (%) in Primary schools in China to that in Congo (Republic)?
Keep it short and to the point. 1.12. What is the ratio of the Gross enrolment ratio (%) in Secondary schools in China to that in Congo (Republic)?
Offer a terse response. 1.51. What is the ratio of the Gross enrolment ratio (%) of Tertiary schools in China to that in Congo (Republic)?
Give a very brief answer. 2.05. What is the ratio of the Gross enrolment ratio (%) of Pre-primary schools in Colombia to that in Congo (Republic)?
Give a very brief answer. 4.07. What is the ratio of the Gross enrolment ratio (%) in Primary schools in Colombia to that in Congo (Republic)?
Give a very brief answer. 2.06. What is the ratio of the Gross enrolment ratio (%) of Secondary schools in Colombia to that in Congo (Republic)?
Make the answer very short. 0.66. What is the ratio of the Gross enrolment ratio (%) of Tertiary schools in Colombia to that in Congo (Republic)?
Provide a succinct answer. 8.16. What is the difference between the highest and the second highest Gross enrolment ratio (%) of Pre-primary schools?
Ensure brevity in your answer.  29.14. What is the difference between the highest and the second highest Gross enrolment ratio (%) in Primary schools?
Your response must be concise. 92.89. What is the difference between the highest and the second highest Gross enrolment ratio (%) in Secondary schools?
Provide a succinct answer. 21.9. What is the difference between the highest and the second highest Gross enrolment ratio (%) of Tertiary schools?
Make the answer very short. 53.48. What is the difference between the highest and the lowest Gross enrolment ratio (%) in Pre-primary schools?
Provide a short and direct response. 83.97. What is the difference between the highest and the lowest Gross enrolment ratio (%) in Primary schools?
Keep it short and to the point. 175.36. What is the difference between the highest and the lowest Gross enrolment ratio (%) of Secondary schools?
Offer a terse response. 83.54. What is the difference between the highest and the lowest Gross enrolment ratio (%) in Tertiary schools?
Make the answer very short. 69.17. 